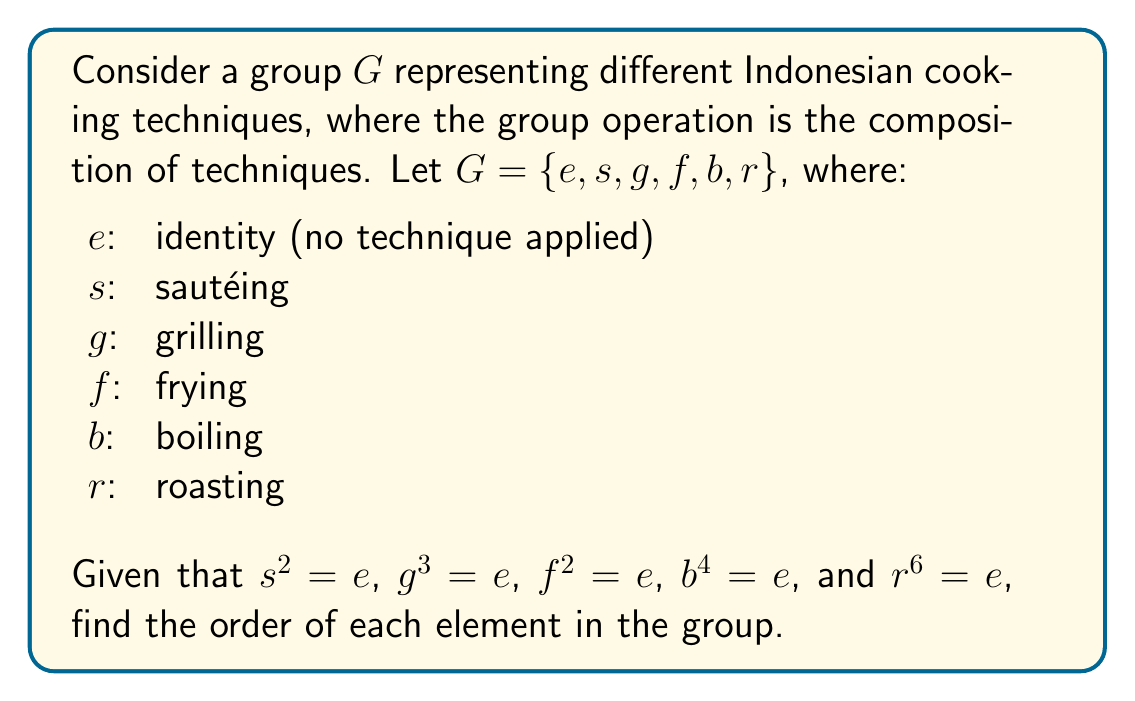Teach me how to tackle this problem. To find the order of each element in the group, we need to determine the smallest positive integer $n$ such that $a^n = e$ for each element $a$ in the group.

1. For the identity element $e$:
   $e^1 = e$, so $|e| = 1$

2. For sautéing $s$:
   Given $s^2 = e$, so $|s| = 2$

3. For grilling $g$:
   Given $g^3 = e$, so $|g| = 3$

4. For frying $f$:
   Given $f^2 = e$, so $|f| = 2$

5. For boiling $b$:
   Given $b^4 = e$, so $|b| = 4$

6. For roasting $r$:
   Given $r^6 = e$, so $|r| = 6$

The order of each element represents how many times the cooking technique needs to be applied to return to the initial state (no technique applied).
Answer: The orders of the elements in the group are:
$|e| = 1$
$|s| = 2$
$|g| = 3$
$|f| = 2$
$|b| = 4$
$|r| = 6$ 